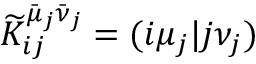Convert formula to latex. <formula><loc_0><loc_0><loc_500><loc_500>\widetilde { K } _ { i j } ^ { \bar { \mu } _ { j } \bar { \nu } _ { j } } = ( i \mu _ { j } | j \nu _ { j } )</formula> 